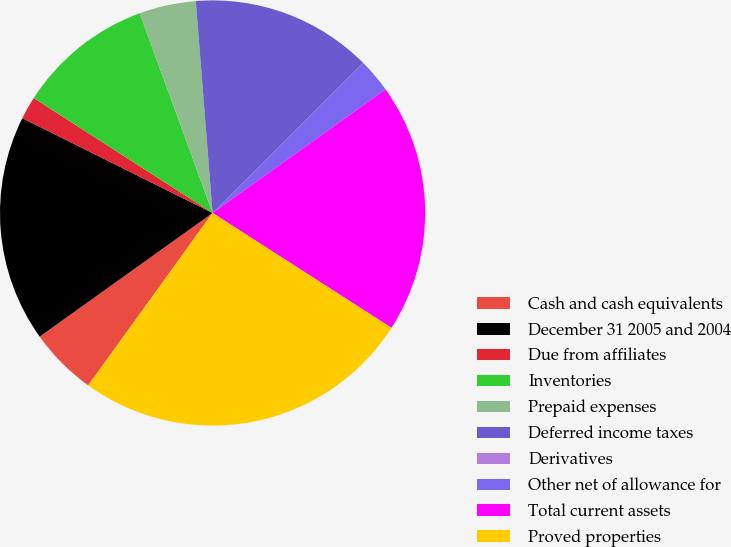Convert chart. <chart><loc_0><loc_0><loc_500><loc_500><pie_chart><fcel>Cash and cash equivalents<fcel>December 31 2005 and 2004<fcel>Due from affiliates<fcel>Inventories<fcel>Prepaid expenses<fcel>Deferred income taxes<fcel>Derivatives<fcel>Other net of allowance for<fcel>Total current assets<fcel>Proved properties<nl><fcel>5.17%<fcel>17.24%<fcel>1.73%<fcel>10.34%<fcel>4.31%<fcel>13.79%<fcel>0.0%<fcel>2.59%<fcel>18.96%<fcel>25.86%<nl></chart> 